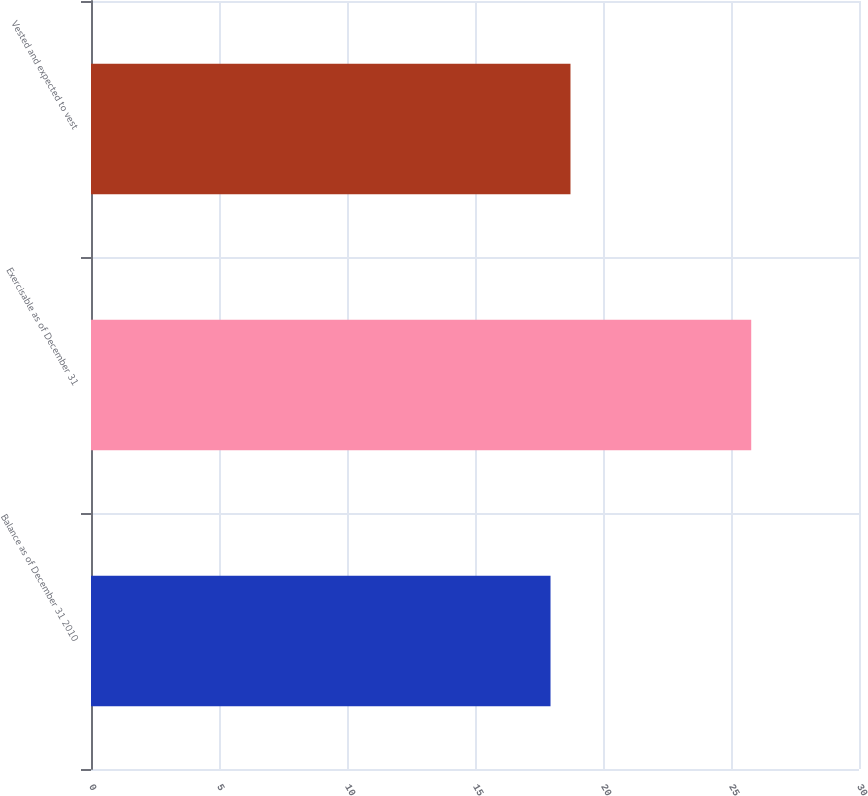Convert chart to OTSL. <chart><loc_0><loc_0><loc_500><loc_500><bar_chart><fcel>Balance as of December 31 2010<fcel>Exercisable as of December 31<fcel>Vested and expected to vest<nl><fcel>17.95<fcel>25.79<fcel>18.73<nl></chart> 